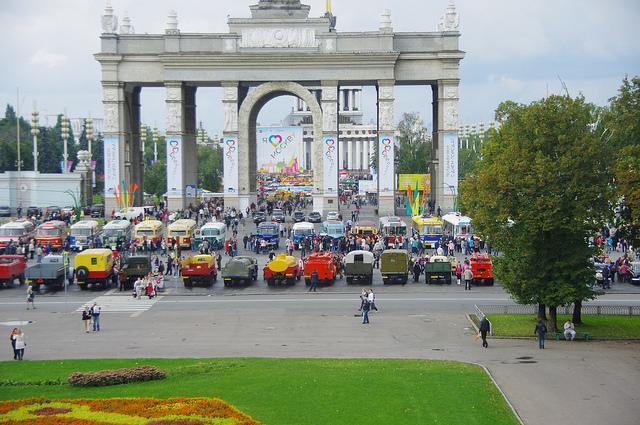How many archways are built into the park entry?
Give a very brief answer. 5. 